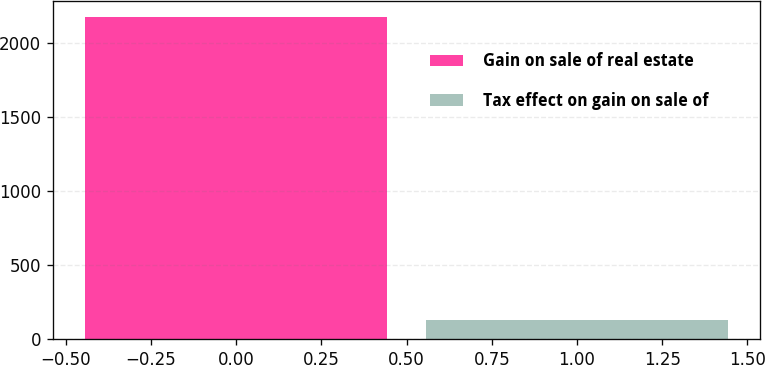Convert chart to OTSL. <chart><loc_0><loc_0><loc_500><loc_500><bar_chart><fcel>Gain on sale of real estate<fcel>Tax effect on gain on sale of<nl><fcel>2180<fcel>130<nl></chart> 